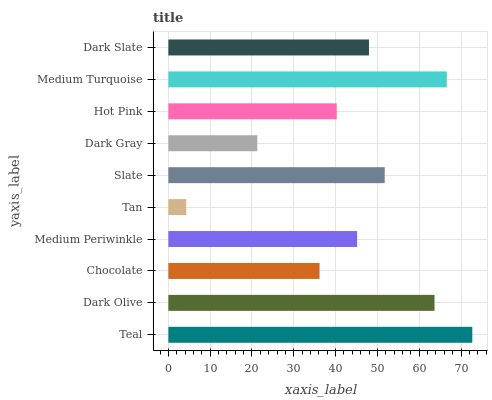Is Tan the minimum?
Answer yes or no. Yes. Is Teal the maximum?
Answer yes or no. Yes. Is Dark Olive the minimum?
Answer yes or no. No. Is Dark Olive the maximum?
Answer yes or no. No. Is Teal greater than Dark Olive?
Answer yes or no. Yes. Is Dark Olive less than Teal?
Answer yes or no. Yes. Is Dark Olive greater than Teal?
Answer yes or no. No. Is Teal less than Dark Olive?
Answer yes or no. No. Is Dark Slate the high median?
Answer yes or no. Yes. Is Medium Periwinkle the low median?
Answer yes or no. Yes. Is Tan the high median?
Answer yes or no. No. Is Dark Slate the low median?
Answer yes or no. No. 